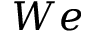Convert formula to latex. <formula><loc_0><loc_0><loc_500><loc_500>W e</formula> 